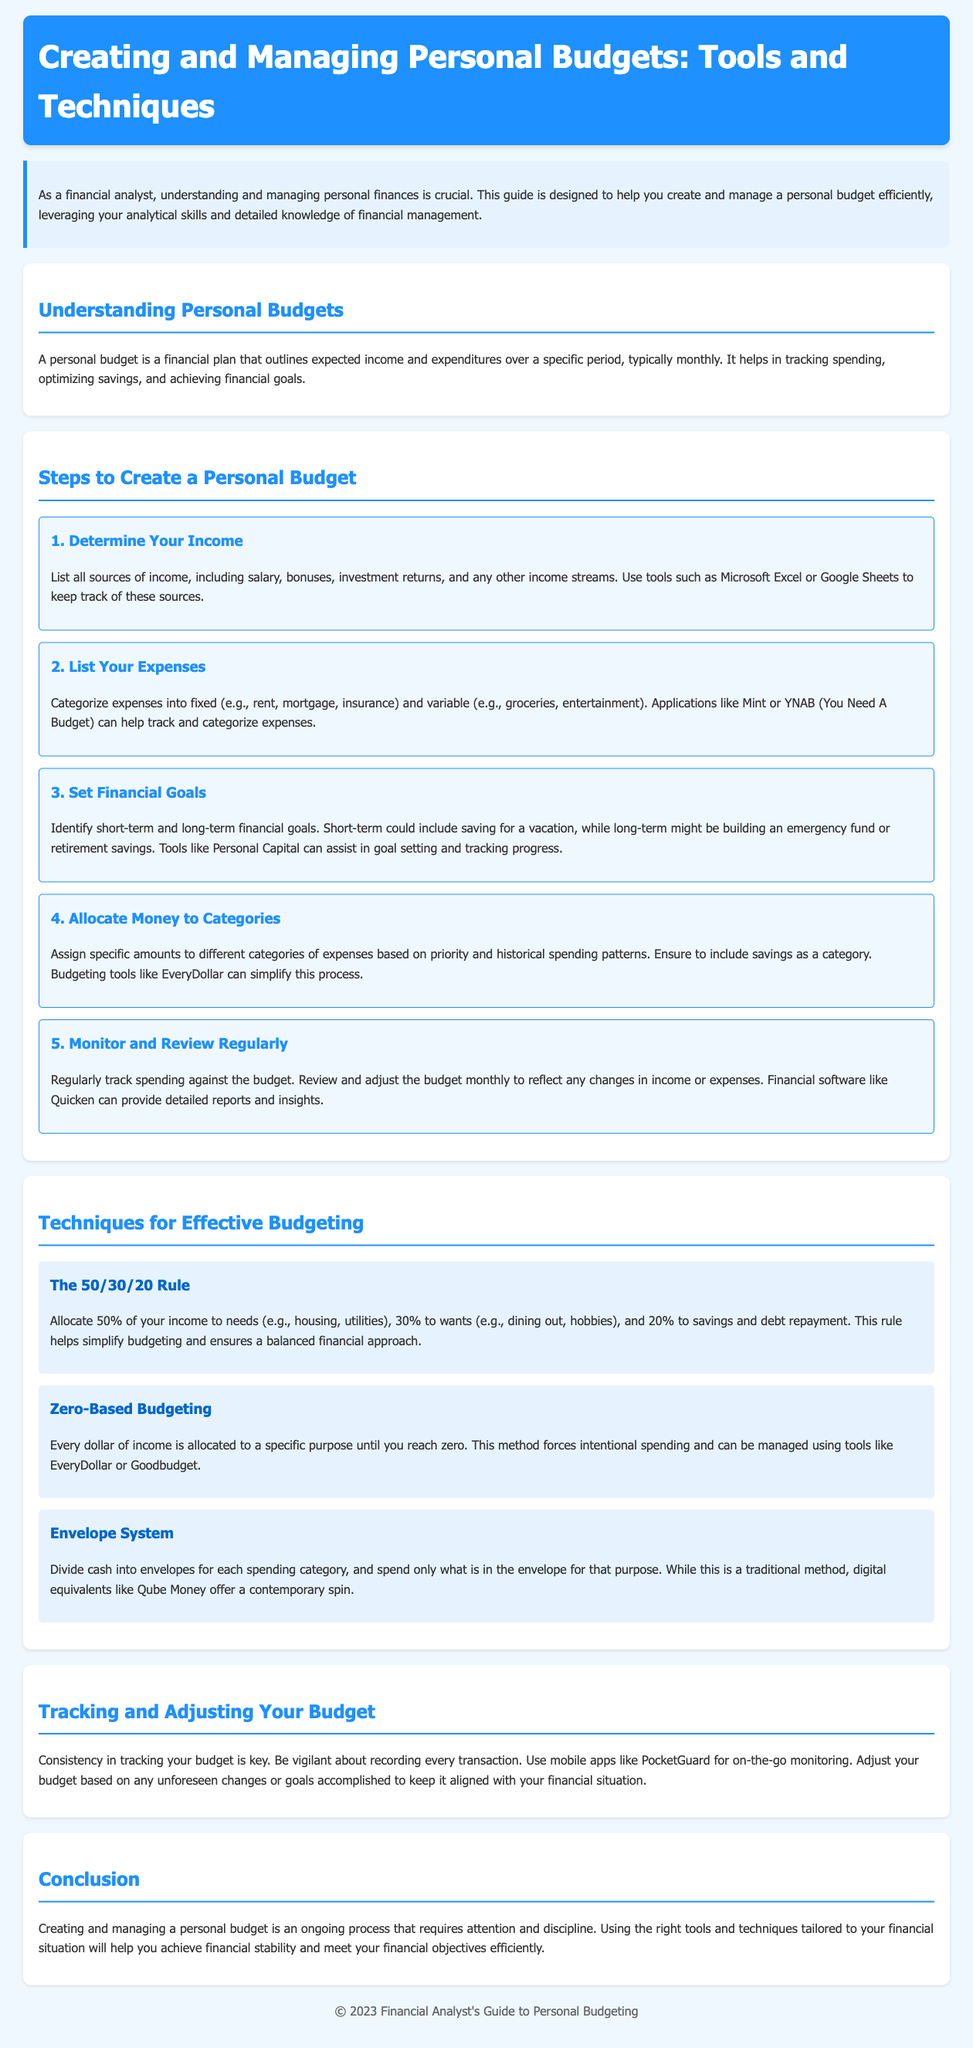What is a personal budget? A personal budget is defined in the document as a financial plan that outlines expected income and expenditures over a specific period, typically monthly.
Answer: A financial plan outlining expected income and expenditures What is the first step in creating a personal budget? The first step involves determining your income, where you need to list all sources of income.
Answer: Determine Your Income What percentage of income should go to needs according to the 50/30/20 rule? The 50/30/20 rule states that 50% of your income should be allocated to needs.
Answer: 50% What tools can help track expenses? The document suggests applications like Mint or YNAB as tools to help track and categorize expenses.
Answer: Mint or YNAB How often should you review and adjust your budget? The guide recommends reviewing and adjusting the budget monthly.
Answer: Monthly What method allocates every dollar of income to a specific purpose until it reaches zero? This budgeting method is called Zero-Based Budgeting.
Answer: Zero-Based Budgeting What is the recommended app for on-the-go budget monitoring? According to the document, mobile apps like PocketGuard are recommended for monitoring budgets on the go.
Answer: PocketGuard What is an important factor in effectively tracking your budget? Consistency in tracking your budget is highlighted as a key factor in the document.
Answer: Consistency What is the primary goal of setting financial goals? The primary goal of setting financial goals is to identify short-term and long-term financial objectives.
Answer: Identify short-term and long-term financial objectives 